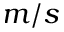Convert formula to latex. <formula><loc_0><loc_0><loc_500><loc_500>m / s</formula> 